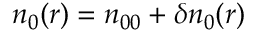<formula> <loc_0><loc_0><loc_500><loc_500>n _ { 0 } ( r ) = n _ { 0 0 } + \delta n _ { 0 } ( r )</formula> 